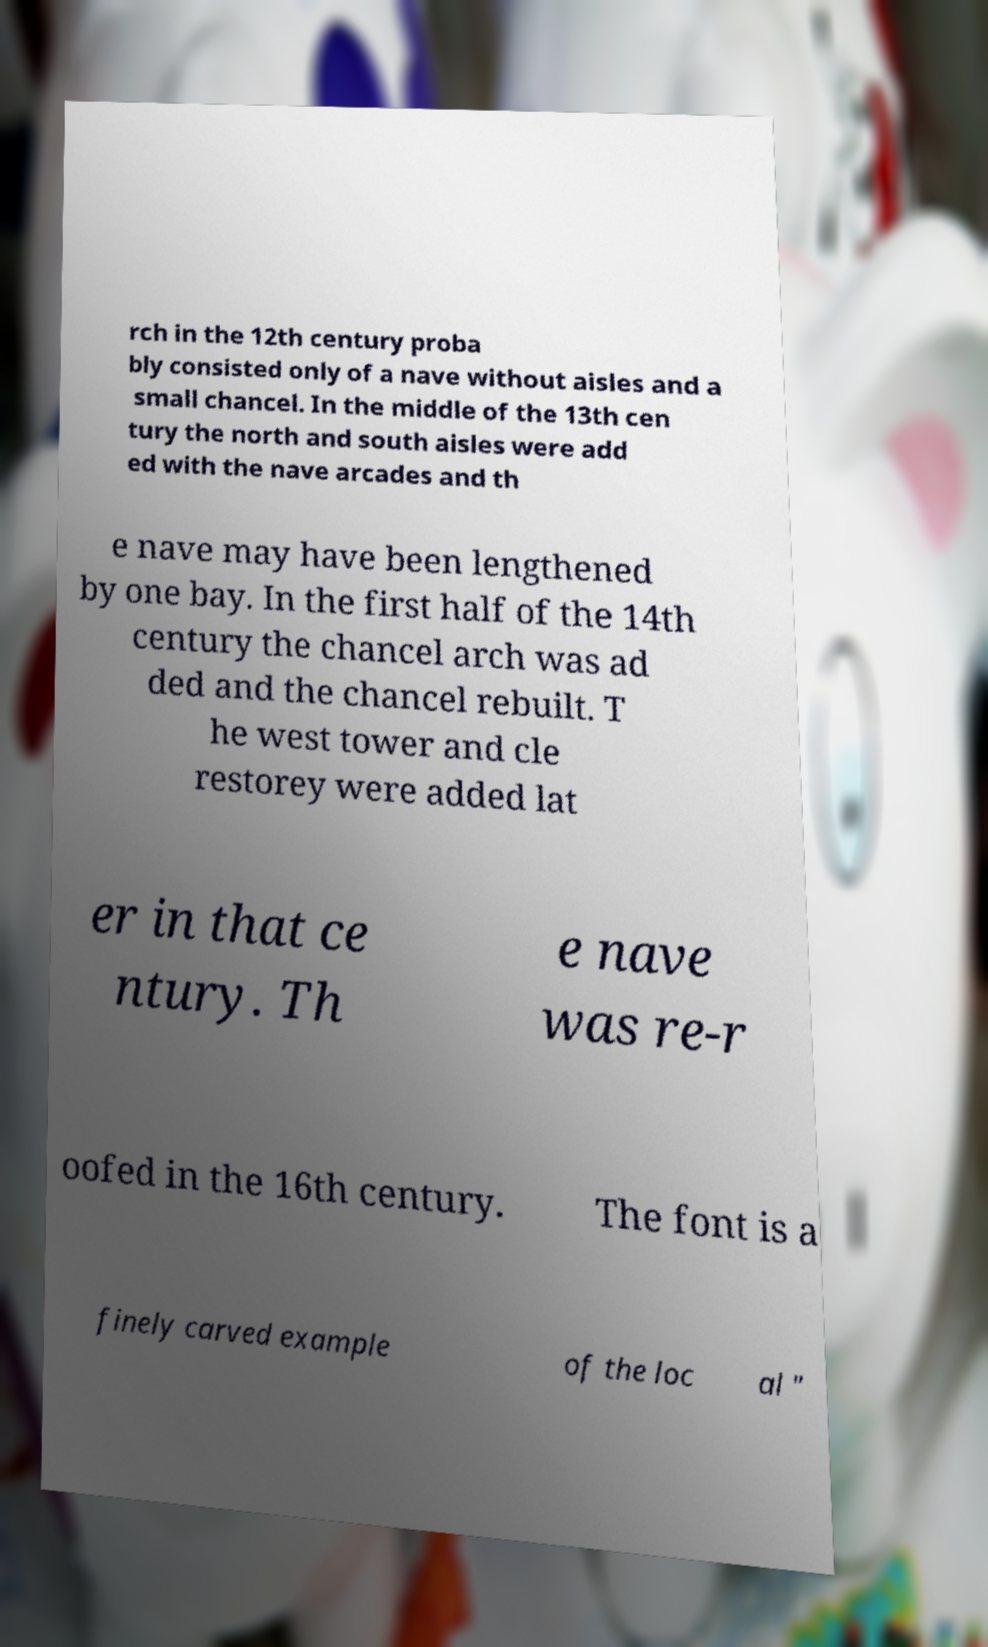There's text embedded in this image that I need extracted. Can you transcribe it verbatim? rch in the 12th century proba bly consisted only of a nave without aisles and a small chancel. In the middle of the 13th cen tury the north and south aisles were add ed with the nave arcades and th e nave may have been lengthened by one bay. In the first half of the 14th century the chancel arch was ad ded and the chancel rebuilt. T he west tower and cle restorey were added lat er in that ce ntury. Th e nave was re-r oofed in the 16th century. The font is a finely carved example of the loc al " 